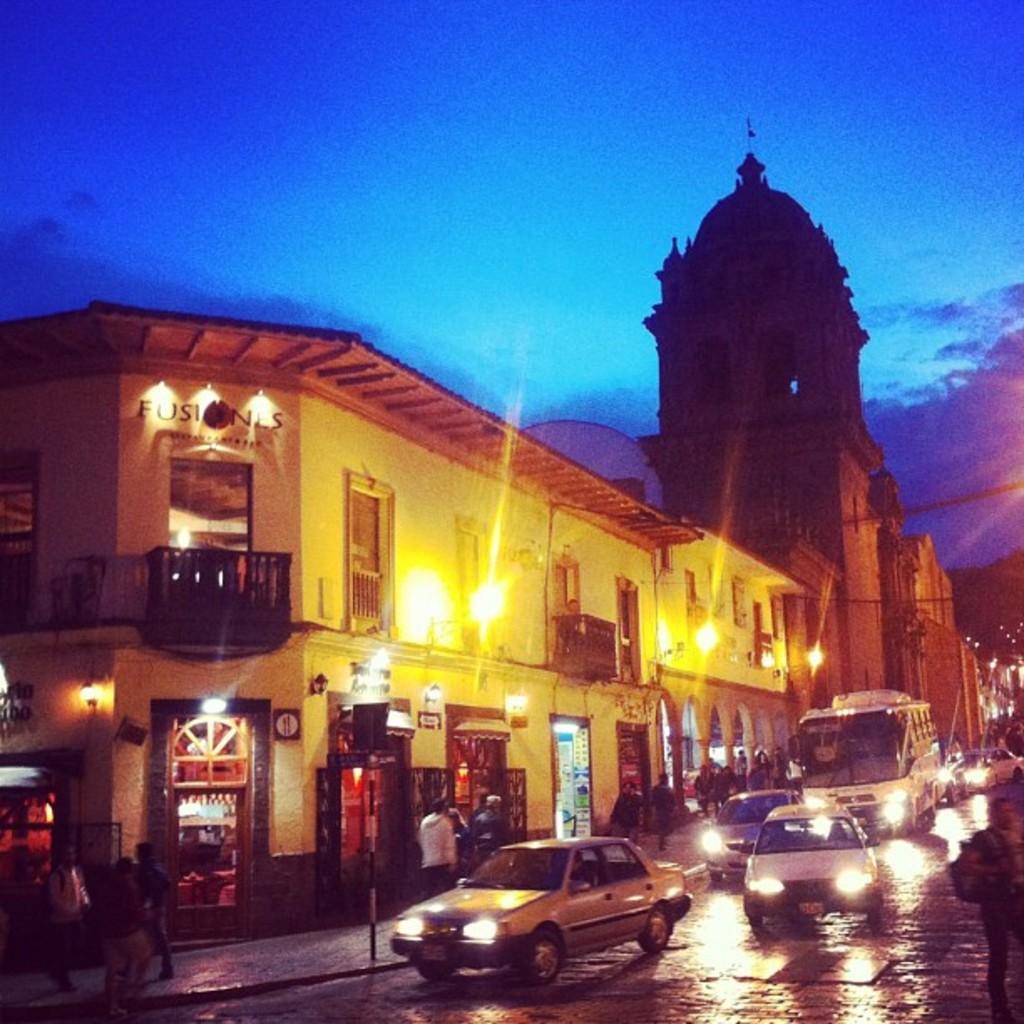Describe this image in one or two sentences. In this image I see the buildings, road on which there are vehicles and I see number of people on the footpath and I see the lights and I see a word written over here. In the background I see the sky and I see the wires. 